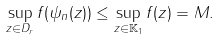Convert formula to latex. <formula><loc_0><loc_0><loc_500><loc_500>\sup _ { z \in D _ { r } } f ( \psi _ { n } ( z ) ) \leq \sup _ { z \in \mathbb { K } _ { 1 } } f ( z ) = M .</formula> 